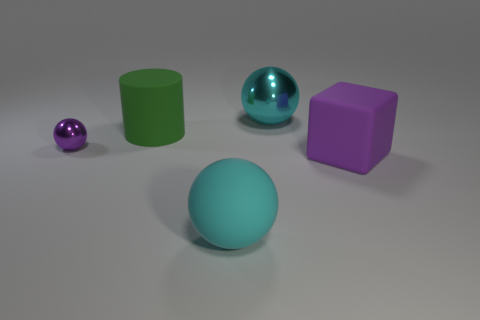How many other things are there of the same size as the purple metallic thing?
Your answer should be very brief. 0. What number of purple balls are the same material as the large cylinder?
Provide a succinct answer. 0. There is a tiny shiny thing that is the same color as the block; what is its shape?
Ensure brevity in your answer.  Sphere. What shape is the green object that is the same size as the purple matte block?
Make the answer very short. Cylinder. There is another sphere that is the same color as the rubber ball; what material is it?
Ensure brevity in your answer.  Metal. There is a big cyan matte sphere; are there any matte cylinders in front of it?
Provide a succinct answer. No. Are there any large yellow metal objects of the same shape as the cyan metal thing?
Provide a short and direct response. No. Is the shape of the large purple object that is on the right side of the green matte object the same as the cyan thing to the left of the cyan shiny object?
Ensure brevity in your answer.  No. Are there any green cylinders that have the same size as the purple ball?
Offer a terse response. No. Are there an equal number of purple rubber things behind the matte cylinder and big metal things on the left side of the tiny purple thing?
Your answer should be very brief. Yes. 